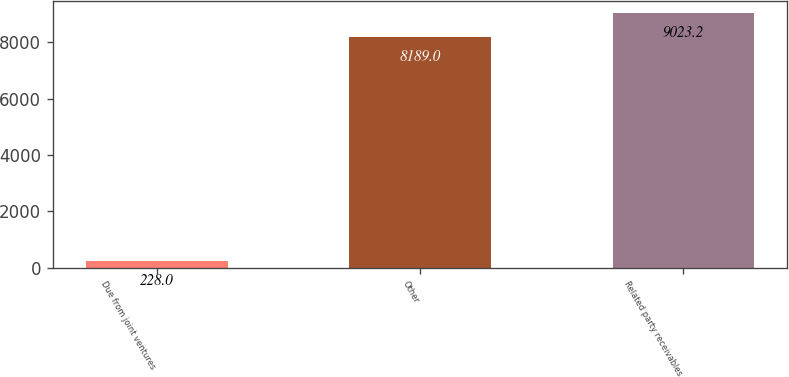Convert chart to OTSL. <chart><loc_0><loc_0><loc_500><loc_500><bar_chart><fcel>Due from joint ventures<fcel>Other<fcel>Related party receivables<nl><fcel>228<fcel>8189<fcel>9023.2<nl></chart> 